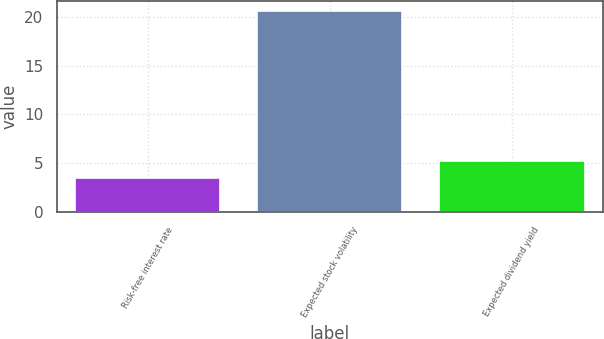<chart> <loc_0><loc_0><loc_500><loc_500><bar_chart><fcel>Risk-free interest rate<fcel>Expected stock volatility<fcel>Expected dividend yield<nl><fcel>3.47<fcel>20.63<fcel>5.19<nl></chart> 